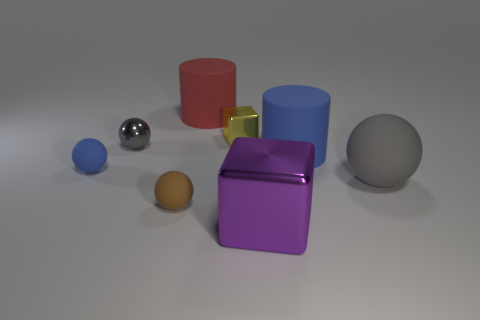Subtract all cyan cylinders. Subtract all blue spheres. How many cylinders are left? 2 Add 1 large purple metallic objects. How many objects exist? 9 Subtract all cylinders. How many objects are left? 6 Subtract 0 red balls. How many objects are left? 8 Subtract all tiny gray matte objects. Subtract all big purple blocks. How many objects are left? 7 Add 2 small yellow metal cubes. How many small yellow metal cubes are left? 3 Add 6 large green metallic cubes. How many large green metallic cubes exist? 6 